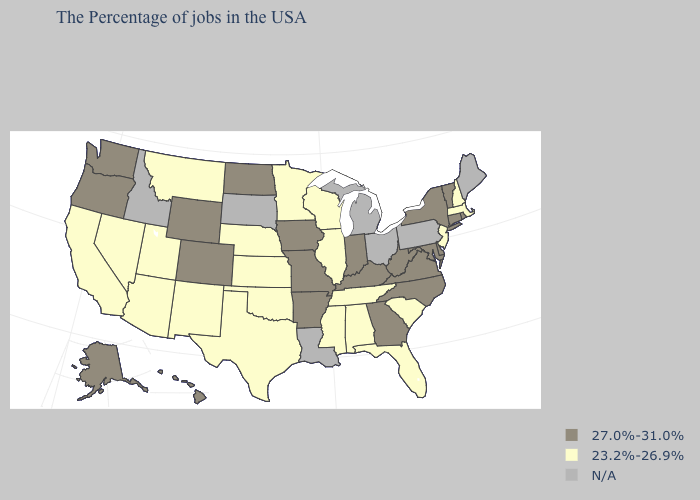Name the states that have a value in the range N/A?
Be succinct. Maine, Pennsylvania, Ohio, Michigan, Louisiana, South Dakota, Idaho. What is the value of Louisiana?
Answer briefly. N/A. What is the value of Texas?
Be succinct. 23.2%-26.9%. Name the states that have a value in the range N/A?
Keep it brief. Maine, Pennsylvania, Ohio, Michigan, Louisiana, South Dakota, Idaho. What is the highest value in the USA?
Give a very brief answer. 27.0%-31.0%. What is the value of Louisiana?
Concise answer only. N/A. What is the value of Nevada?
Give a very brief answer. 23.2%-26.9%. Name the states that have a value in the range N/A?
Concise answer only. Maine, Pennsylvania, Ohio, Michigan, Louisiana, South Dakota, Idaho. Is the legend a continuous bar?
Quick response, please. No. What is the lowest value in the USA?
Quick response, please. 23.2%-26.9%. Among the states that border Nevada , which have the lowest value?
Quick response, please. Utah, Arizona, California. What is the value of Florida?
Quick response, please. 23.2%-26.9%. What is the value of South Dakota?
Quick response, please. N/A. What is the highest value in the Northeast ?
Quick response, please. 27.0%-31.0%. Name the states that have a value in the range 23.2%-26.9%?
Short answer required. Massachusetts, New Hampshire, New Jersey, South Carolina, Florida, Alabama, Tennessee, Wisconsin, Illinois, Mississippi, Minnesota, Kansas, Nebraska, Oklahoma, Texas, New Mexico, Utah, Montana, Arizona, Nevada, California. 